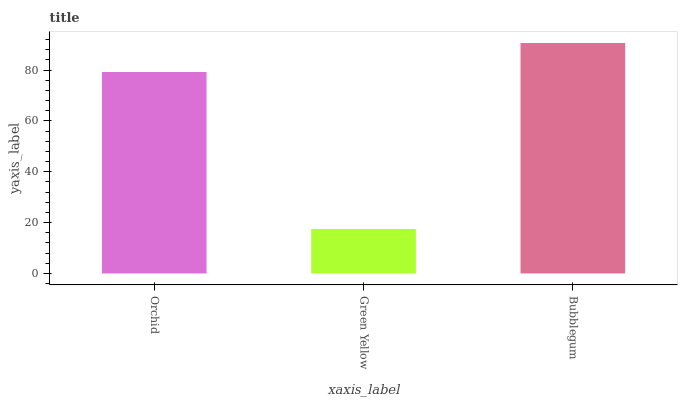Is Green Yellow the minimum?
Answer yes or no. Yes. Is Bubblegum the maximum?
Answer yes or no. Yes. Is Bubblegum the minimum?
Answer yes or no. No. Is Green Yellow the maximum?
Answer yes or no. No. Is Bubblegum greater than Green Yellow?
Answer yes or no. Yes. Is Green Yellow less than Bubblegum?
Answer yes or no. Yes. Is Green Yellow greater than Bubblegum?
Answer yes or no. No. Is Bubblegum less than Green Yellow?
Answer yes or no. No. Is Orchid the high median?
Answer yes or no. Yes. Is Orchid the low median?
Answer yes or no. Yes. Is Bubblegum the high median?
Answer yes or no. No. Is Green Yellow the low median?
Answer yes or no. No. 